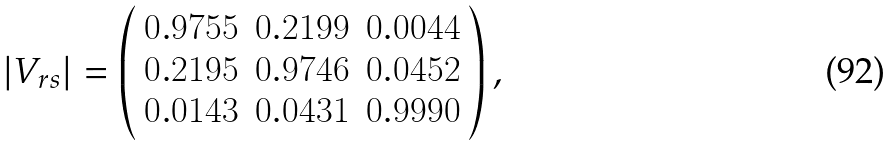<formula> <loc_0><loc_0><loc_500><loc_500>| V _ { r s } | = \left ( \begin{array} { c c c } 0 . 9 7 5 5 & 0 . 2 1 9 9 & 0 . 0 0 4 4 \\ 0 . 2 1 9 5 & 0 . 9 7 4 6 & 0 . 0 4 5 2 \\ 0 . 0 1 4 3 & 0 . 0 4 3 1 & 0 . 9 9 9 0 \end{array} \right ) ,</formula> 